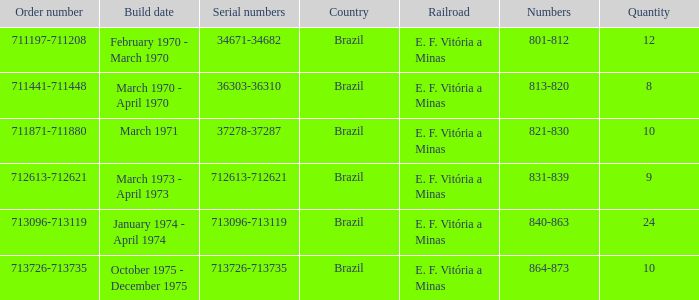How many railroads have the numbers 864-873? 1.0. 